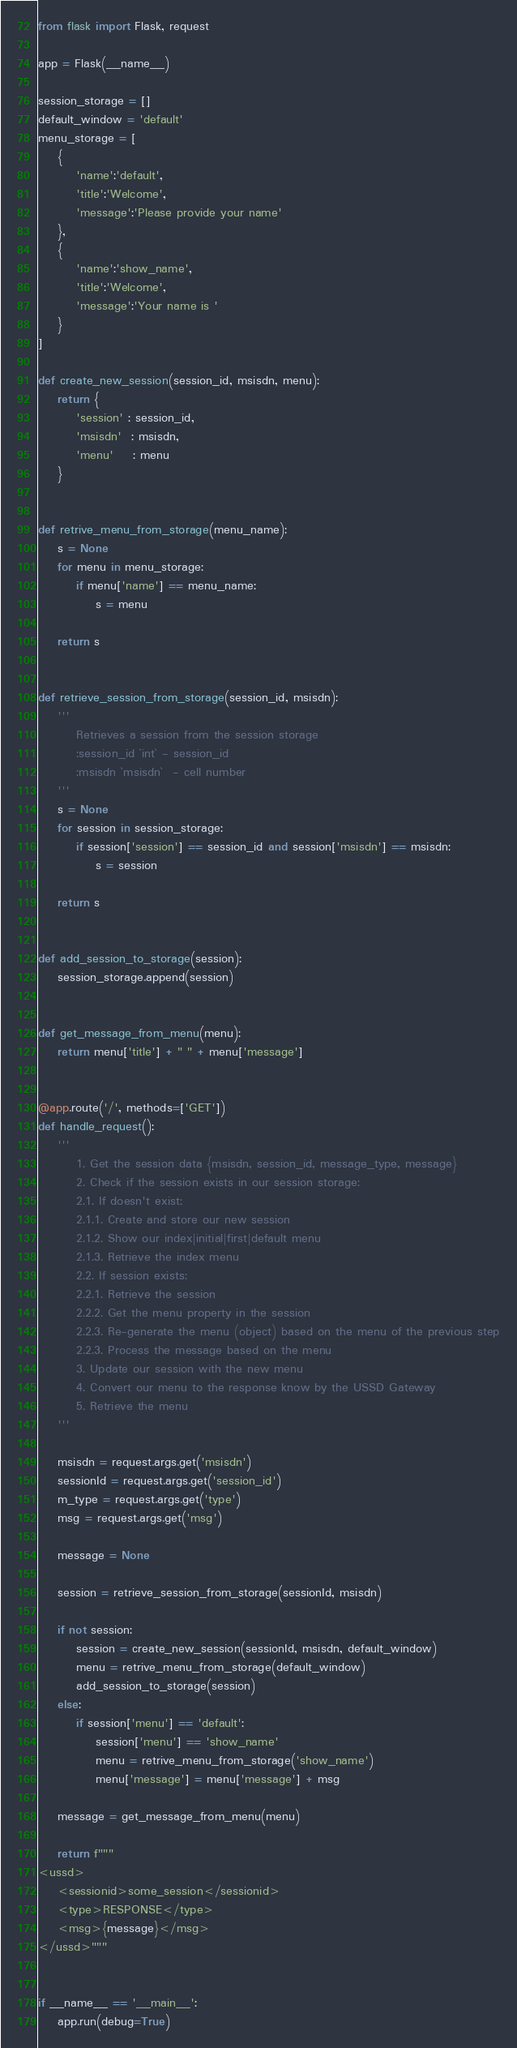<code> <loc_0><loc_0><loc_500><loc_500><_Python_>from flask import Flask, request

app = Flask(__name__)

session_storage = []
default_window = 'default'
menu_storage = [
    {
        'name':'default',
        'title':'Welcome',
        'message':'Please provide your name'
    },
    {
        'name':'show_name',
        'title':'Welcome',
        'message':'Your name is '
    }
]

def create_new_session(session_id, msisdn, menu):
    return {
        'session' : session_id,
        'msisdn'  : msisdn,
        'menu'    : menu
    }


def retrive_menu_from_storage(menu_name):
    s = None
    for menu in menu_storage:
        if menu['name'] == menu_name:
            s = menu

    return s


def retrieve_session_from_storage(session_id, msisdn):
    '''
        Retrieves a session from the session storage
        :session_id `int` - session_id
        :msisdn `msisdn`  - cell number
    '''
    s = None
    for session in session_storage:
        if session['session'] == session_id and session['msisdn'] == msisdn:
            s = session

    return s


def add_session_to_storage(session):
    session_storage.append(session)


def get_message_from_menu(menu):
    return menu['title'] + " " + menu['message']


@app.route('/', methods=['GET'])
def handle_request():
    '''
        1. Get the session data {msisdn, session_id, message_type, message}
        2. Check if the session exists in our session storage:
        2.1. If doesn't exist:
        2.1.1. Create and store our new session
        2.1.2. Show our index|initial|first|default menu
        2.1.3. Retrieve the index menu
        2.2. If session exists:
        2.2.1. Retrieve the session
        2.2.2. Get the menu property in the session
        2.2.3. Re-generate the menu (object) based on the menu of the previous step
        2.2.3. Process the message based on the menu
        3. Update our session with the new menu
        4. Convert our menu to the response know by the USSD Gateway
        5. Retrieve the menu
    '''

    msisdn = request.args.get('msisdn') 
    sessionId = request.args.get('session_id') 
    m_type = request.args.get('type') 
    msg = request.args.get('msg') 

    message = None

    session = retrieve_session_from_storage(sessionId, msisdn)

    if not session:
        session = create_new_session(sessionId, msisdn, default_window)
        menu = retrive_menu_from_storage(default_window)
        add_session_to_storage(session)
    else:
        if session['menu'] == 'default':
            session['menu'] == 'show_name'
            menu = retrive_menu_from_storage('show_name')
            menu['message'] = menu['message'] + msg

    message = get_message_from_menu(menu)

    return f"""
<ussd>
	<sessionid>some_session</sessionid>
	<type>RESPONSE</type>
	<msg>{message}</msg>
</ussd>"""


if __name__ == '__main__':
    app.run(debug=True)</code> 